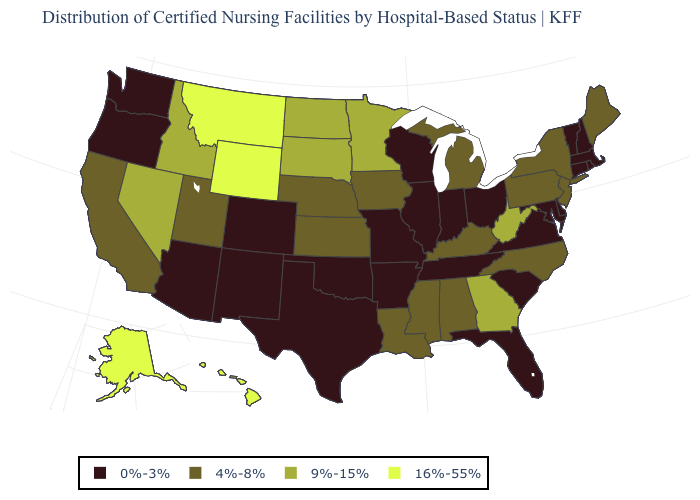Name the states that have a value in the range 4%-8%?
Keep it brief. Alabama, California, Iowa, Kansas, Kentucky, Louisiana, Maine, Michigan, Mississippi, Nebraska, New Jersey, New York, North Carolina, Pennsylvania, Utah. Name the states that have a value in the range 0%-3%?
Answer briefly. Arizona, Arkansas, Colorado, Connecticut, Delaware, Florida, Illinois, Indiana, Maryland, Massachusetts, Missouri, New Hampshire, New Mexico, Ohio, Oklahoma, Oregon, Rhode Island, South Carolina, Tennessee, Texas, Vermont, Virginia, Washington, Wisconsin. Does Delaware have a lower value than Wyoming?
Be succinct. Yes. Does Hawaii have the lowest value in the West?
Quick response, please. No. Name the states that have a value in the range 9%-15%?
Concise answer only. Georgia, Idaho, Minnesota, Nevada, North Dakota, South Dakota, West Virginia. Is the legend a continuous bar?
Short answer required. No. What is the highest value in the USA?
Answer briefly. 16%-55%. What is the value of Texas?
Write a very short answer. 0%-3%. What is the value of Maine?
Quick response, please. 4%-8%. Does Hawaii have a lower value than Connecticut?
Concise answer only. No. Does Indiana have a lower value than Ohio?
Keep it brief. No. Name the states that have a value in the range 16%-55%?
Concise answer only. Alaska, Hawaii, Montana, Wyoming. Does Maryland have the lowest value in the USA?
Keep it brief. Yes. What is the highest value in states that border Missouri?
Write a very short answer. 4%-8%. What is the value of Arizona?
Be succinct. 0%-3%. 